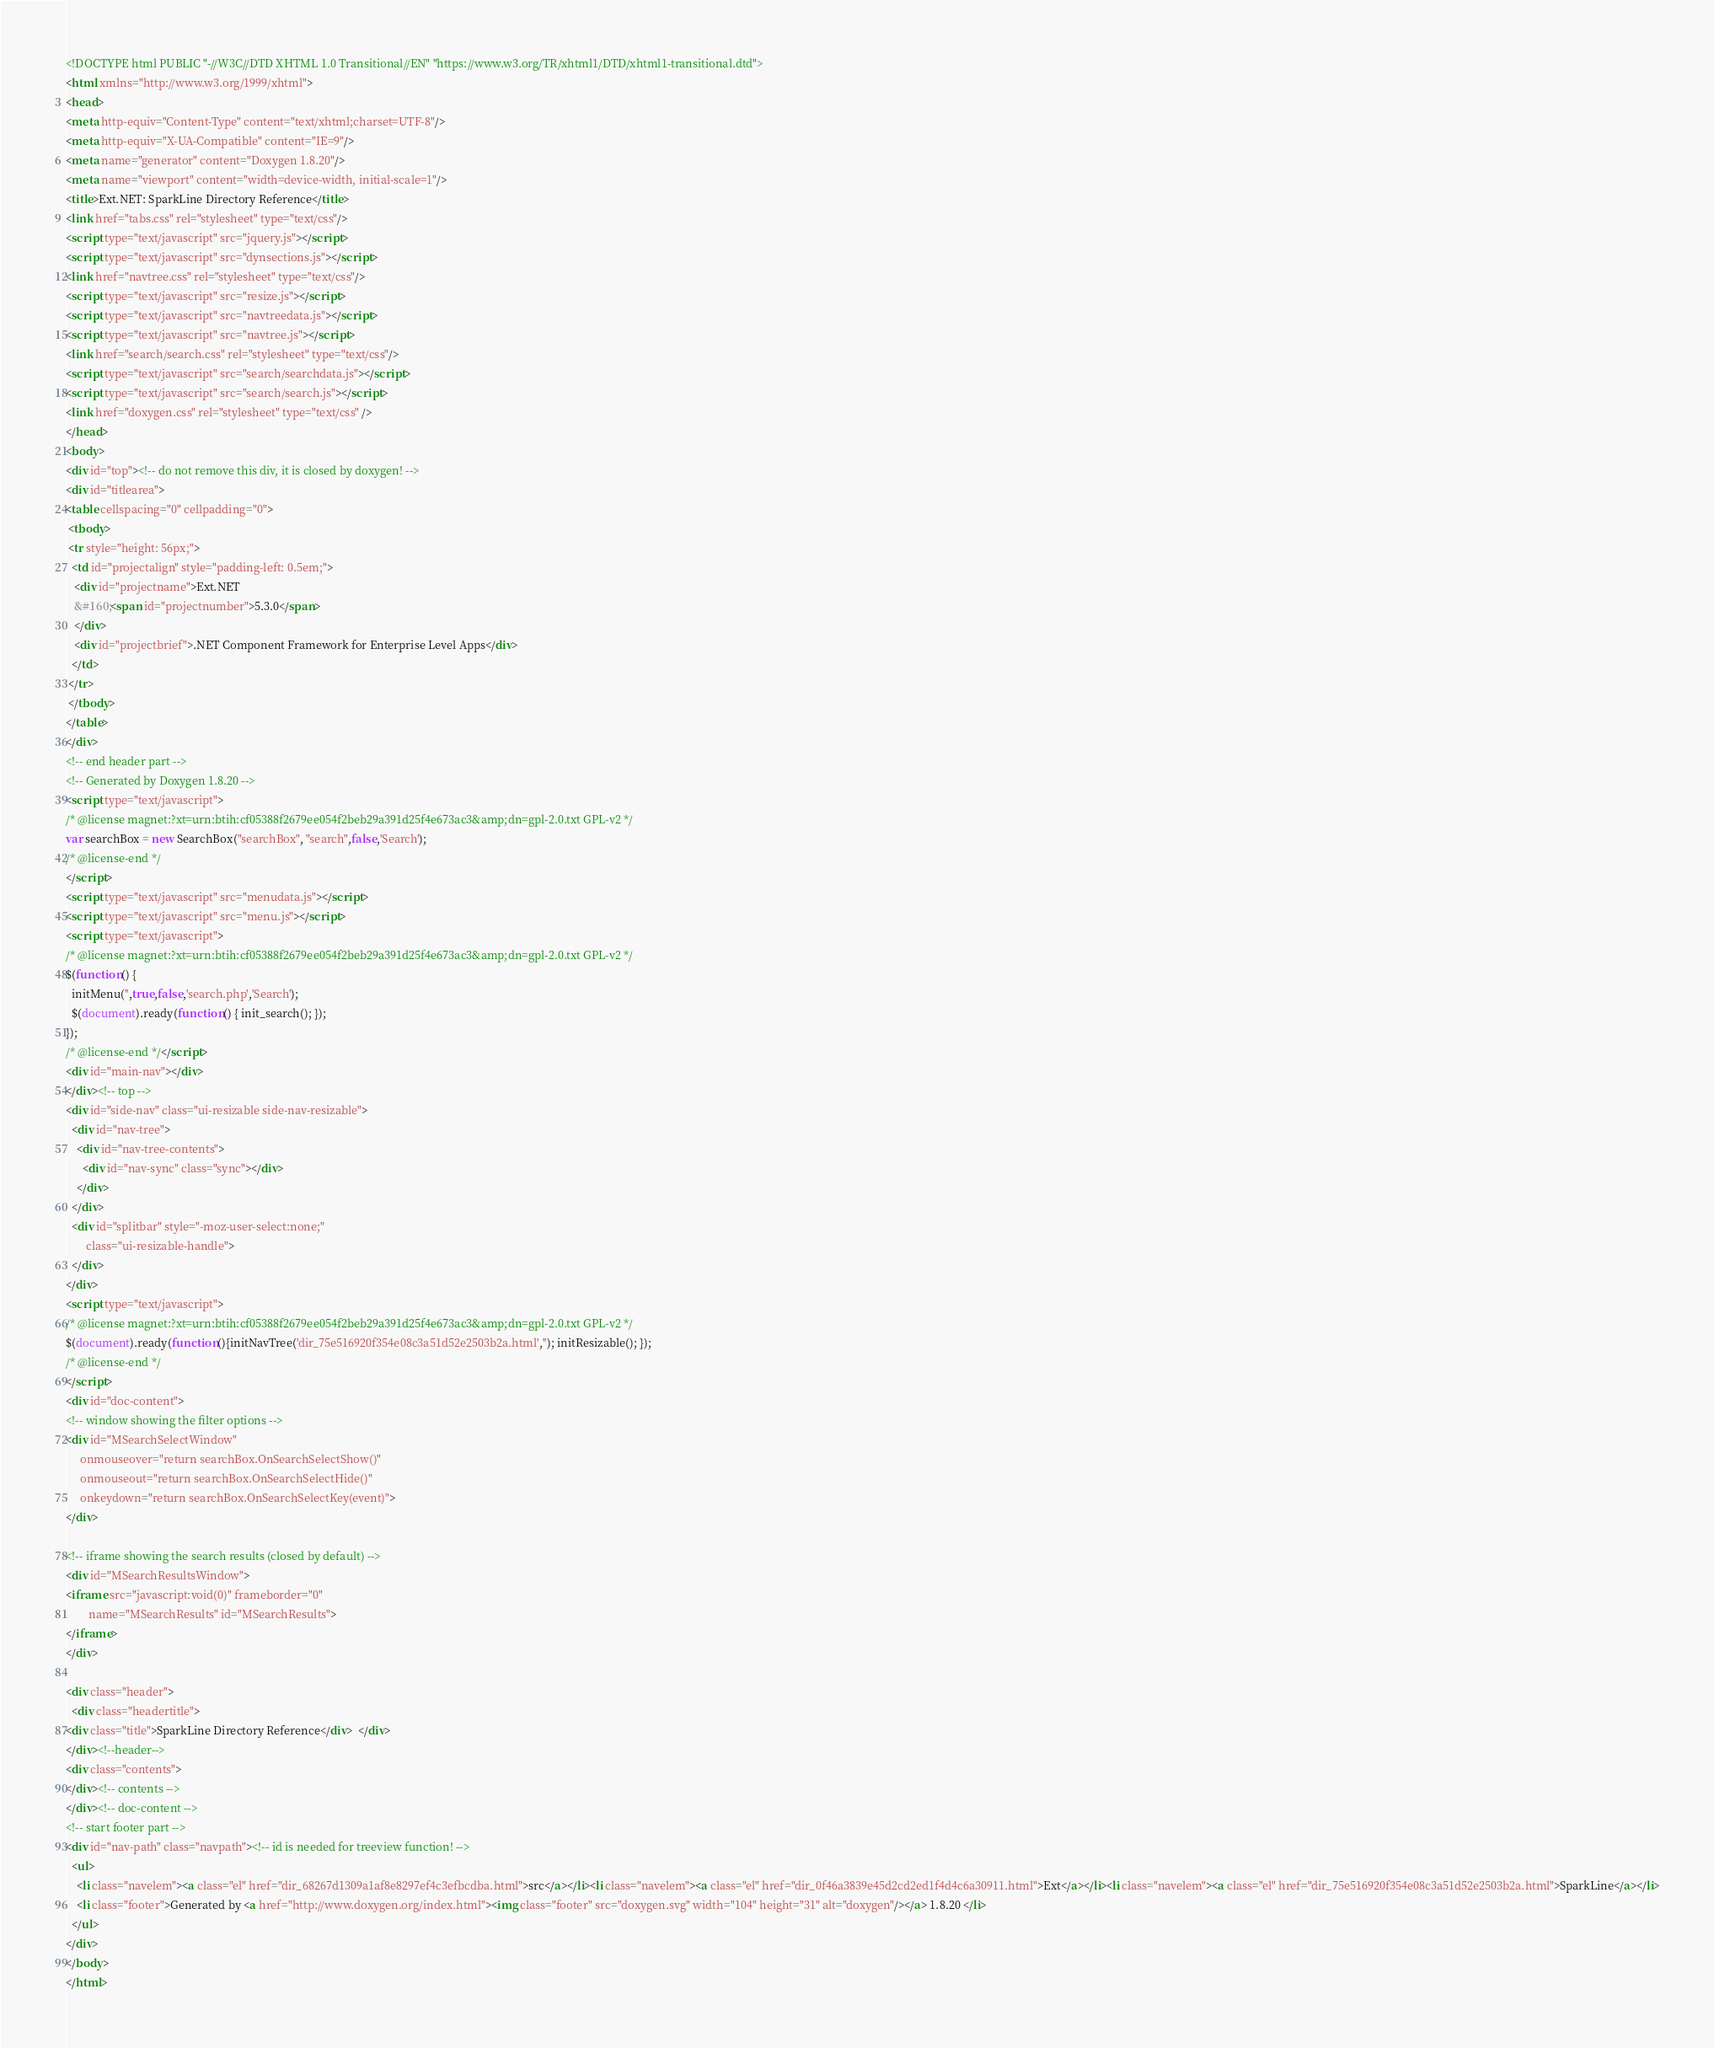<code> <loc_0><loc_0><loc_500><loc_500><_HTML_><!DOCTYPE html PUBLIC "-//W3C//DTD XHTML 1.0 Transitional//EN" "https://www.w3.org/TR/xhtml1/DTD/xhtml1-transitional.dtd">
<html xmlns="http://www.w3.org/1999/xhtml">
<head>
<meta http-equiv="Content-Type" content="text/xhtml;charset=UTF-8"/>
<meta http-equiv="X-UA-Compatible" content="IE=9"/>
<meta name="generator" content="Doxygen 1.8.20"/>
<meta name="viewport" content="width=device-width, initial-scale=1"/>
<title>Ext.NET: SparkLine Directory Reference</title>
<link href="tabs.css" rel="stylesheet" type="text/css"/>
<script type="text/javascript" src="jquery.js"></script>
<script type="text/javascript" src="dynsections.js"></script>
<link href="navtree.css" rel="stylesheet" type="text/css"/>
<script type="text/javascript" src="resize.js"></script>
<script type="text/javascript" src="navtreedata.js"></script>
<script type="text/javascript" src="navtree.js"></script>
<link href="search/search.css" rel="stylesheet" type="text/css"/>
<script type="text/javascript" src="search/searchdata.js"></script>
<script type="text/javascript" src="search/search.js"></script>
<link href="doxygen.css" rel="stylesheet" type="text/css" />
</head>
<body>
<div id="top"><!-- do not remove this div, it is closed by doxygen! -->
<div id="titlearea">
<table cellspacing="0" cellpadding="0">
 <tbody>
 <tr style="height: 56px;">
  <td id="projectalign" style="padding-left: 0.5em;">
   <div id="projectname">Ext.NET
   &#160;<span id="projectnumber">5.3.0</span>
   </div>
   <div id="projectbrief">.NET Component Framework for Enterprise Level Apps</div>
  </td>
 </tr>
 </tbody>
</table>
</div>
<!-- end header part -->
<!-- Generated by Doxygen 1.8.20 -->
<script type="text/javascript">
/* @license magnet:?xt=urn:btih:cf05388f2679ee054f2beb29a391d25f4e673ac3&amp;dn=gpl-2.0.txt GPL-v2 */
var searchBox = new SearchBox("searchBox", "search",false,'Search');
/* @license-end */
</script>
<script type="text/javascript" src="menudata.js"></script>
<script type="text/javascript" src="menu.js"></script>
<script type="text/javascript">
/* @license magnet:?xt=urn:btih:cf05388f2679ee054f2beb29a391d25f4e673ac3&amp;dn=gpl-2.0.txt GPL-v2 */
$(function() {
  initMenu('',true,false,'search.php','Search');
  $(document).ready(function() { init_search(); });
});
/* @license-end */</script>
<div id="main-nav"></div>
</div><!-- top -->
<div id="side-nav" class="ui-resizable side-nav-resizable">
  <div id="nav-tree">
    <div id="nav-tree-contents">
      <div id="nav-sync" class="sync"></div>
    </div>
  </div>
  <div id="splitbar" style="-moz-user-select:none;" 
       class="ui-resizable-handle">
  </div>
</div>
<script type="text/javascript">
/* @license magnet:?xt=urn:btih:cf05388f2679ee054f2beb29a391d25f4e673ac3&amp;dn=gpl-2.0.txt GPL-v2 */
$(document).ready(function(){initNavTree('dir_75e516920f354e08c3a51d52e2503b2a.html',''); initResizable(); });
/* @license-end */
</script>
<div id="doc-content">
<!-- window showing the filter options -->
<div id="MSearchSelectWindow"
     onmouseover="return searchBox.OnSearchSelectShow()"
     onmouseout="return searchBox.OnSearchSelectHide()"
     onkeydown="return searchBox.OnSearchSelectKey(event)">
</div>

<!-- iframe showing the search results (closed by default) -->
<div id="MSearchResultsWindow">
<iframe src="javascript:void(0)" frameborder="0" 
        name="MSearchResults" id="MSearchResults">
</iframe>
</div>

<div class="header">
  <div class="headertitle">
<div class="title">SparkLine Directory Reference</div>  </div>
</div><!--header-->
<div class="contents">
</div><!-- contents -->
</div><!-- doc-content -->
<!-- start footer part -->
<div id="nav-path" class="navpath"><!-- id is needed for treeview function! -->
  <ul>
    <li class="navelem"><a class="el" href="dir_68267d1309a1af8e8297ef4c3efbcdba.html">src</a></li><li class="navelem"><a class="el" href="dir_0f46a3839e45d2cd2ed1f4d4c6a30911.html">Ext</a></li><li class="navelem"><a class="el" href="dir_75e516920f354e08c3a51d52e2503b2a.html">SparkLine</a></li>
    <li class="footer">Generated by <a href="http://www.doxygen.org/index.html"><img class="footer" src="doxygen.svg" width="104" height="31" alt="doxygen"/></a> 1.8.20 </li>
  </ul>
</div>
</body>
</html>
</code> 